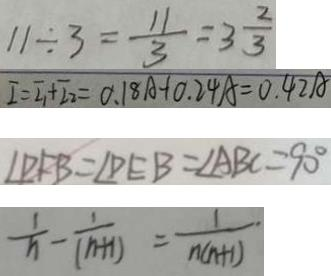Convert formula to latex. <formula><loc_0><loc_0><loc_500><loc_500>1 1 \div 3 = \frac { 1 1 } { 3 } = 3 \frac { 2 } { 3 } 
 I = I _ { 1 } + I _ { 2 } = 0 . 1 8 A + 0 . 2 4 A = 0 . 4 2 A 
 \angle D F B = \angle D E B = \angle A B C = 9 0 ^ { \circ } 
 \frac { 1 } { n } - \frac { 1 } { ( n + 1 ) } = \frac { 1 } { n ( n + 1 ) }</formula> 